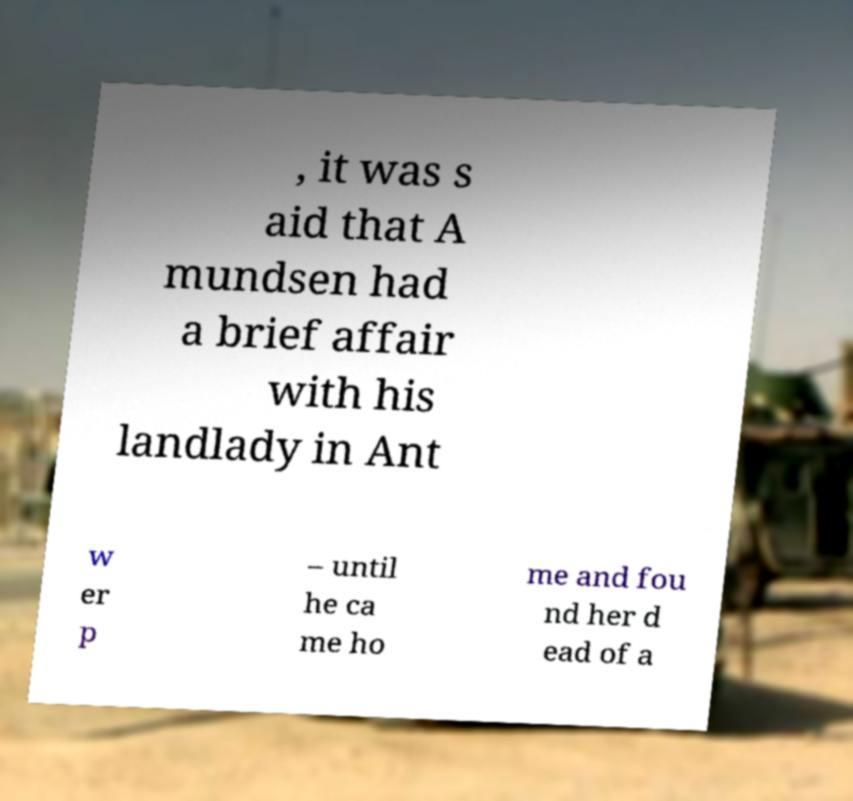Can you accurately transcribe the text from the provided image for me? , it was s aid that A mundsen had a brief affair with his landlady in Ant w er p – until he ca me ho me and fou nd her d ead of a 